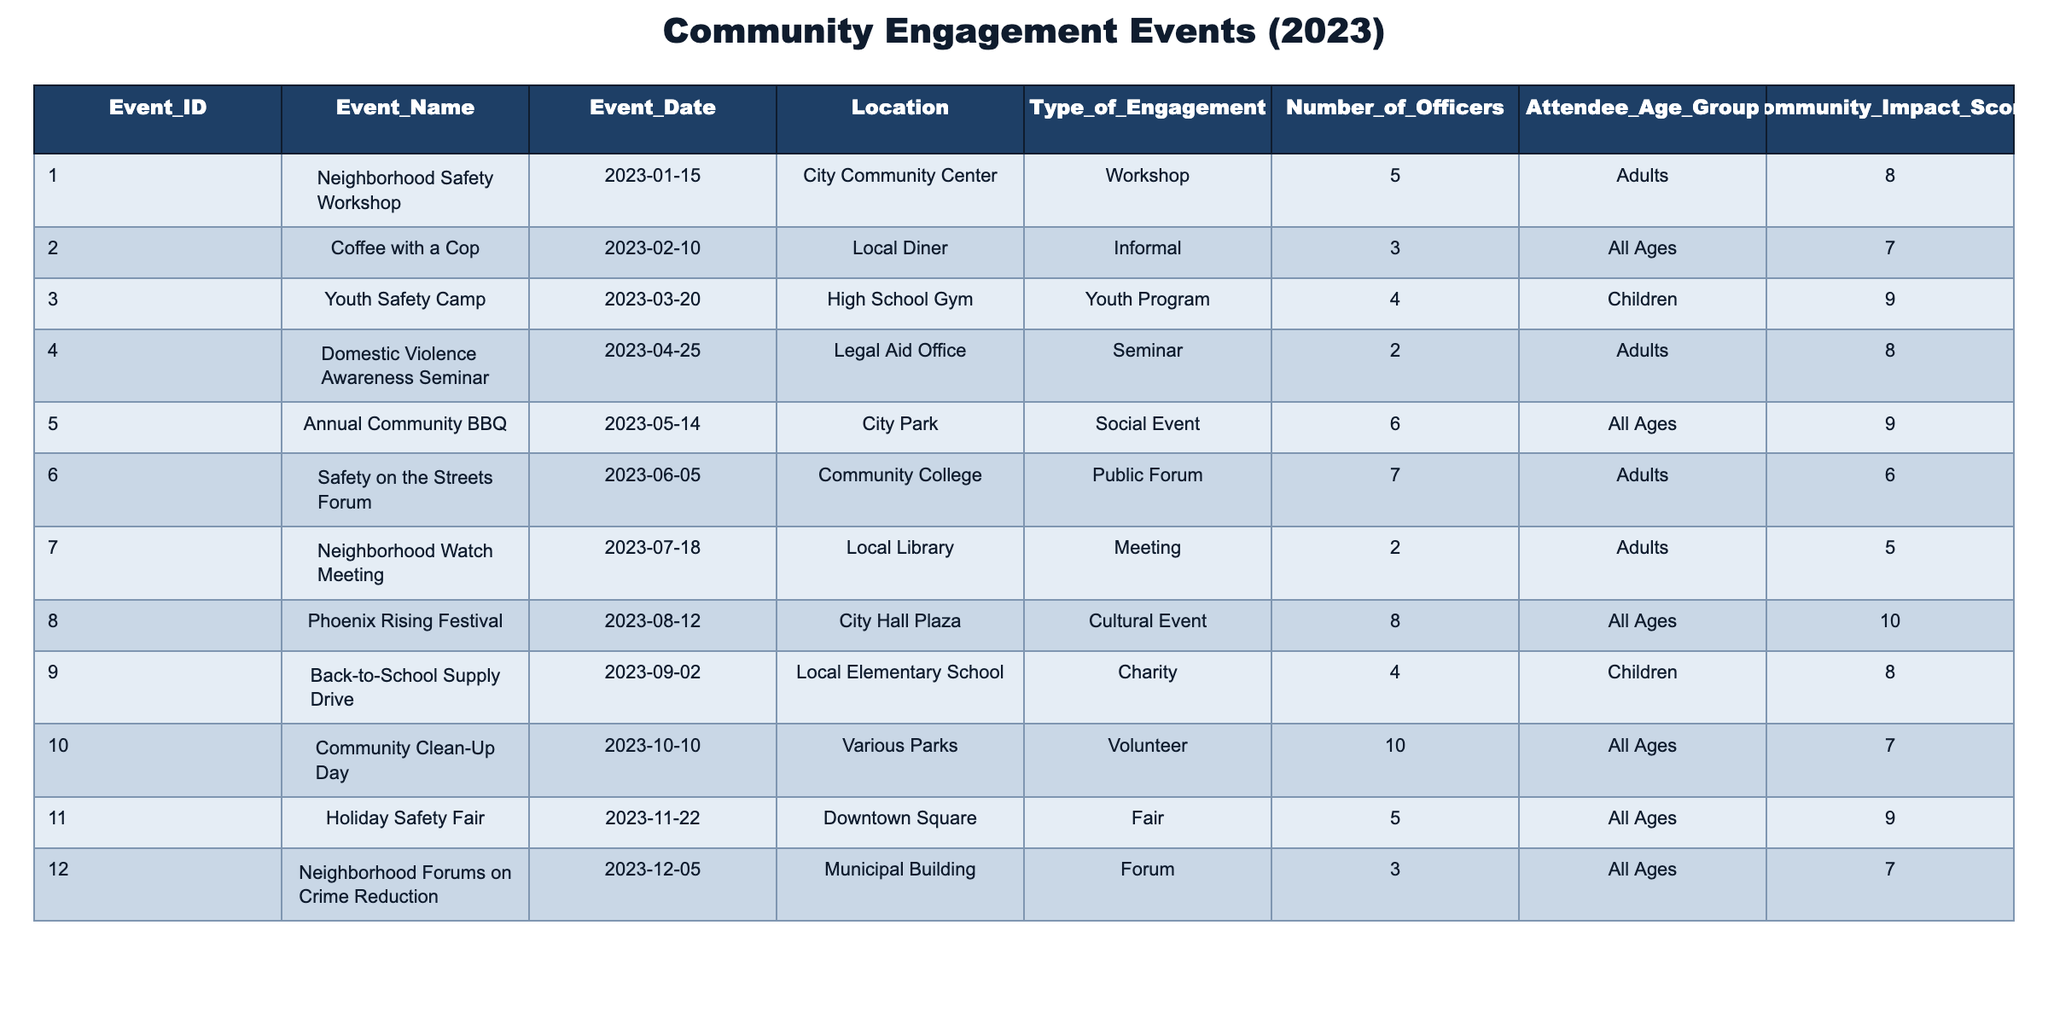What is the most attended community engagement event? The event with the highest number of officers attending is the "Community Clean-Up Day" with 10 officers. This can be determined by looking at the 'Number of Officers' column and identifying the maximum value.
Answer: Community Clean-Up Day Which event had the highest community impact score? The event with the highest community impact score is the "Phoenix Rising Festival," which scored 10. This is found by checking the 'Community Impact Score' column and locating the maximum score.
Answer: Phoenix Rising Festival What is the total number of officers who attended all events? To find the total number of officers, we sum the 'Number of Officers' column: 5 + 3 + 4 + 2 + 6 + 7 + 2 + 8 + 4 + 10 + 5 + 3 = 59 officers. Therefore, by adding each row's officer count, we find the total.
Answer: 59 How many informal engagements were conducted? There was one informal engagement event titled "Coffee with a Cop." By referencing the 'Type of Engagement' column and counting the instances of "Informal," we determine the number of such engagements.
Answer: 1 Did any events specifically target children? Yes, two events specifically targeted children: "Youth Safety Camp" and "Back-to-School Supply Drive." These events can be identified by checking the 'Attendee Age Group' column for entries marked "Children."
Answer: Yes What is the average community impact score of all events? First, we add all the community impact scores: 8 + 7 + 9 + 8 + 9 + 6 + 5 + 10 + 8 + 7 + 9 + 7 = 100. Then we divide by the number of events, which is 12. The average score is 100/12 = 8.33. This calculation shows the mean impact score across all listed events.
Answer: 8.33 How many events had a community impact score less than 7? There were four events with a community impact score less than 7: "Safety on the Streets Forum," "Neighborhood Watch Meeting," and possibly others depending on numerical checks. By evaluating the 'Community Impact Score' column and counting instances under 7, we conclude that there are four such events.
Answer: 4 Which month had the most events and how many? June had three events: "Safety on the Streets Forum," "Neighborhood Watch Meeting," and "Annual Community BBQ." We check each event's date to see which month had the highest count, and here June has the most events.
Answer: June, 3 events 